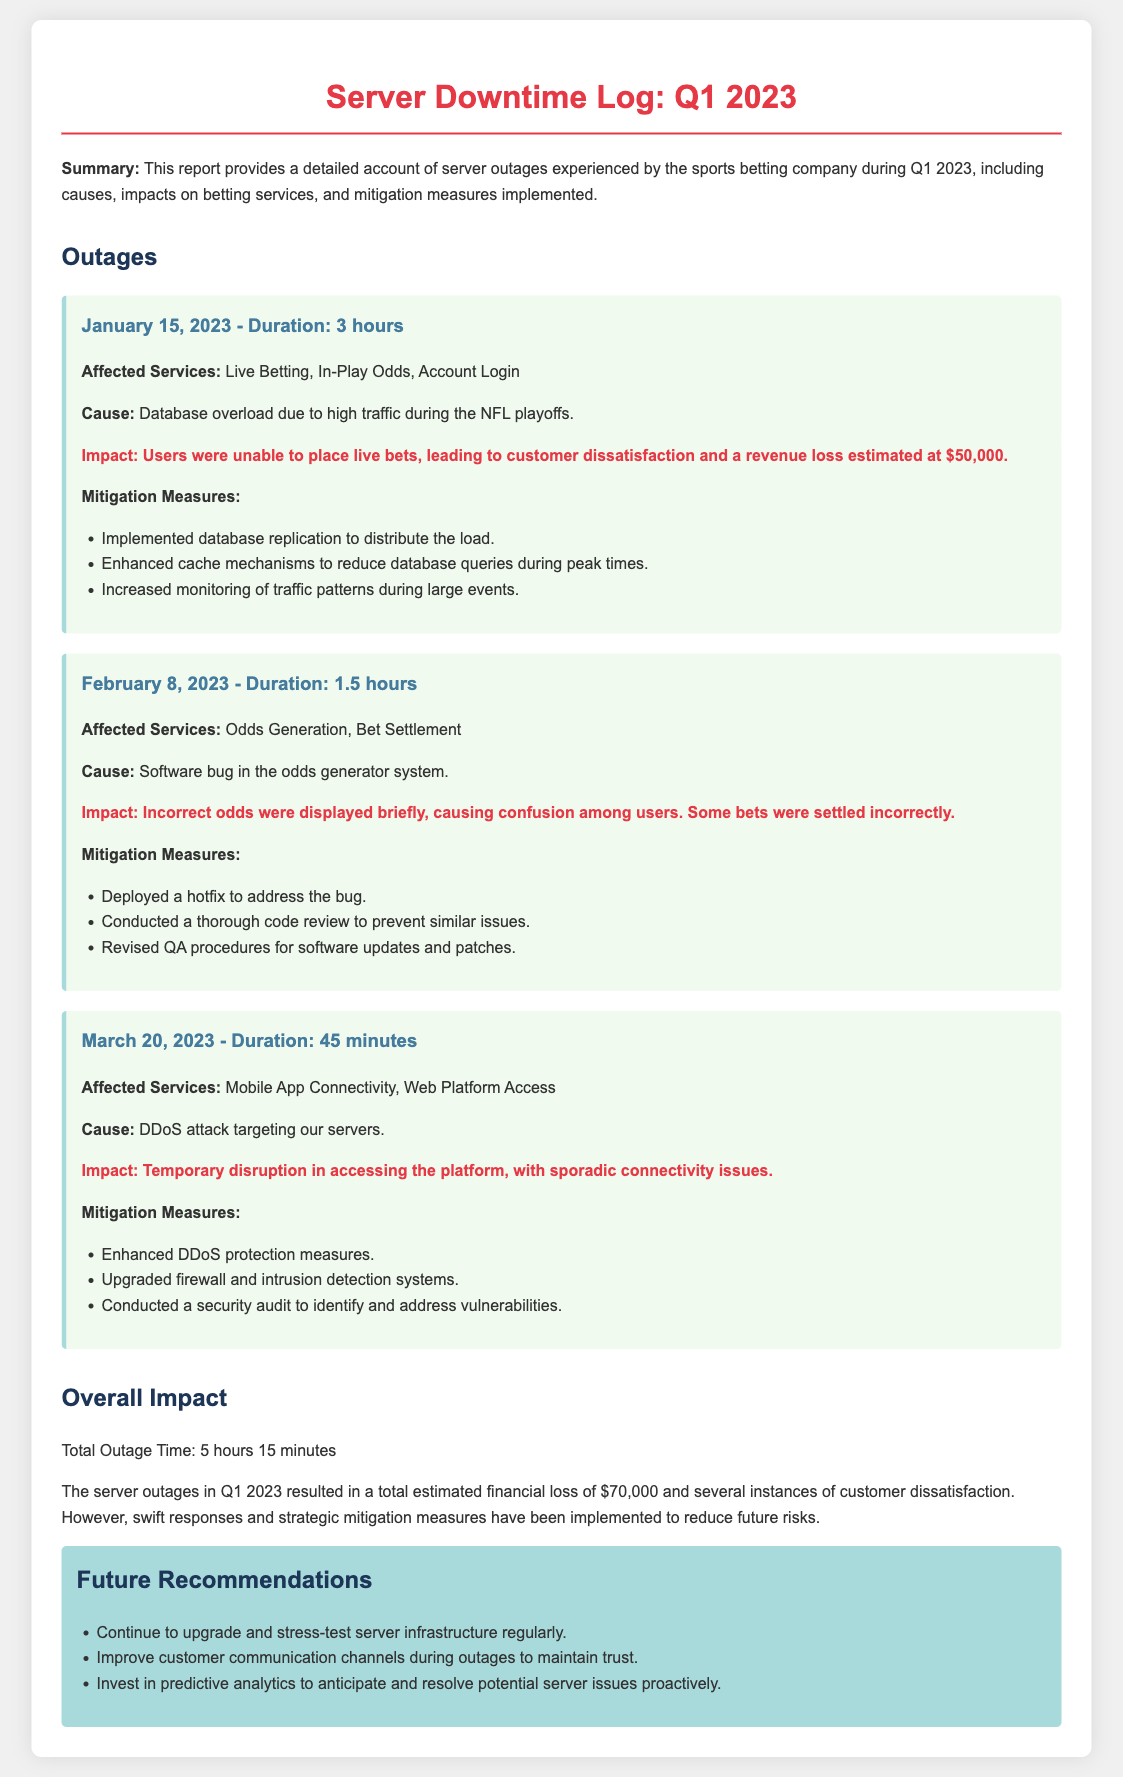What was the date of the first outage? The first outage occurred on January 15, 2023.
Answer: January 15, 2023 How long did the outage on February 8, 2023, last? The outage on February 8, 2023, lasted 1.5 hours.
Answer: 1.5 hours What was the estimated revenue loss from all outages? The total estimated financial loss from outages was $70,000.
Answer: $70,000 What caused the outage on March 20, 2023? The cause of the March 20, 2023, outage was a DDoS attack.
Answer: DDoS attack What mitigation measure was taken for the January 15, 2023, outage? One of the measures was implementing database replication to distribute the load.
Answer: Database replication What type of services were affected during all outages? The affected services included Live Betting, Odds Generation, and Mobile App Connectivity.
Answer: Live Betting, Odds Generation, and Mobile App Connectivity What is one of the future recommendations mentioned in the report? One recommendation is to improve customer communication channels during outages.
Answer: Improve customer communication channels What was the impact of the February 8, 2023, outage? The impact was confusion among users due to incorrect odds being displayed.
Answer: Confusion among users How many outages occurred in Q1 2023? There were three outages recorded in the document for Q1 2023.
Answer: Three 